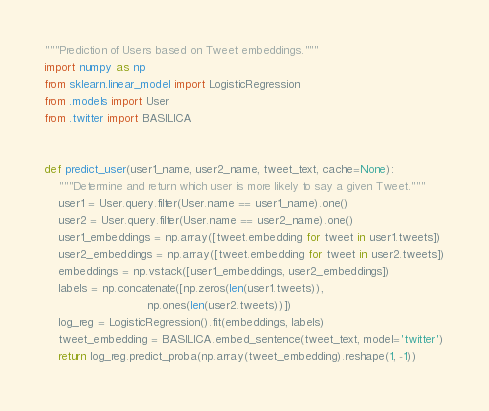Convert code to text. <code><loc_0><loc_0><loc_500><loc_500><_Python_>"""Prediction of Users based on Tweet embeddings."""
import numpy as np
from sklearn.linear_model import LogisticRegression
from .models import User
from .twitter import BASILICA


def predict_user(user1_name, user2_name, tweet_text, cache=None):
    """Determine and return which user is more likely to say a given Tweet."""
    user1 = User.query.filter(User.name == user1_name).one()
    user2 = User.query.filter(User.name == user2_name).one()
    user1_embeddings = np.array([tweet.embedding for tweet in user1.tweets])
    user2_embeddings = np.array([tweet.embedding for tweet in user2.tweets])
    embeddings = np.vstack([user1_embeddings, user2_embeddings])
    labels = np.concatenate([np.zeros(len(user1.tweets)),
                             np.ones(len(user2.tweets))])
    log_reg = LogisticRegression().fit(embeddings, labels)
    tweet_embedding = BASILICA.embed_sentence(tweet_text, model='twitter')
    return log_reg.predict_proba(np.array(tweet_embedding).reshape(1, -1))</code> 